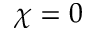<formula> <loc_0><loc_0><loc_500><loc_500>\chi = 0</formula> 